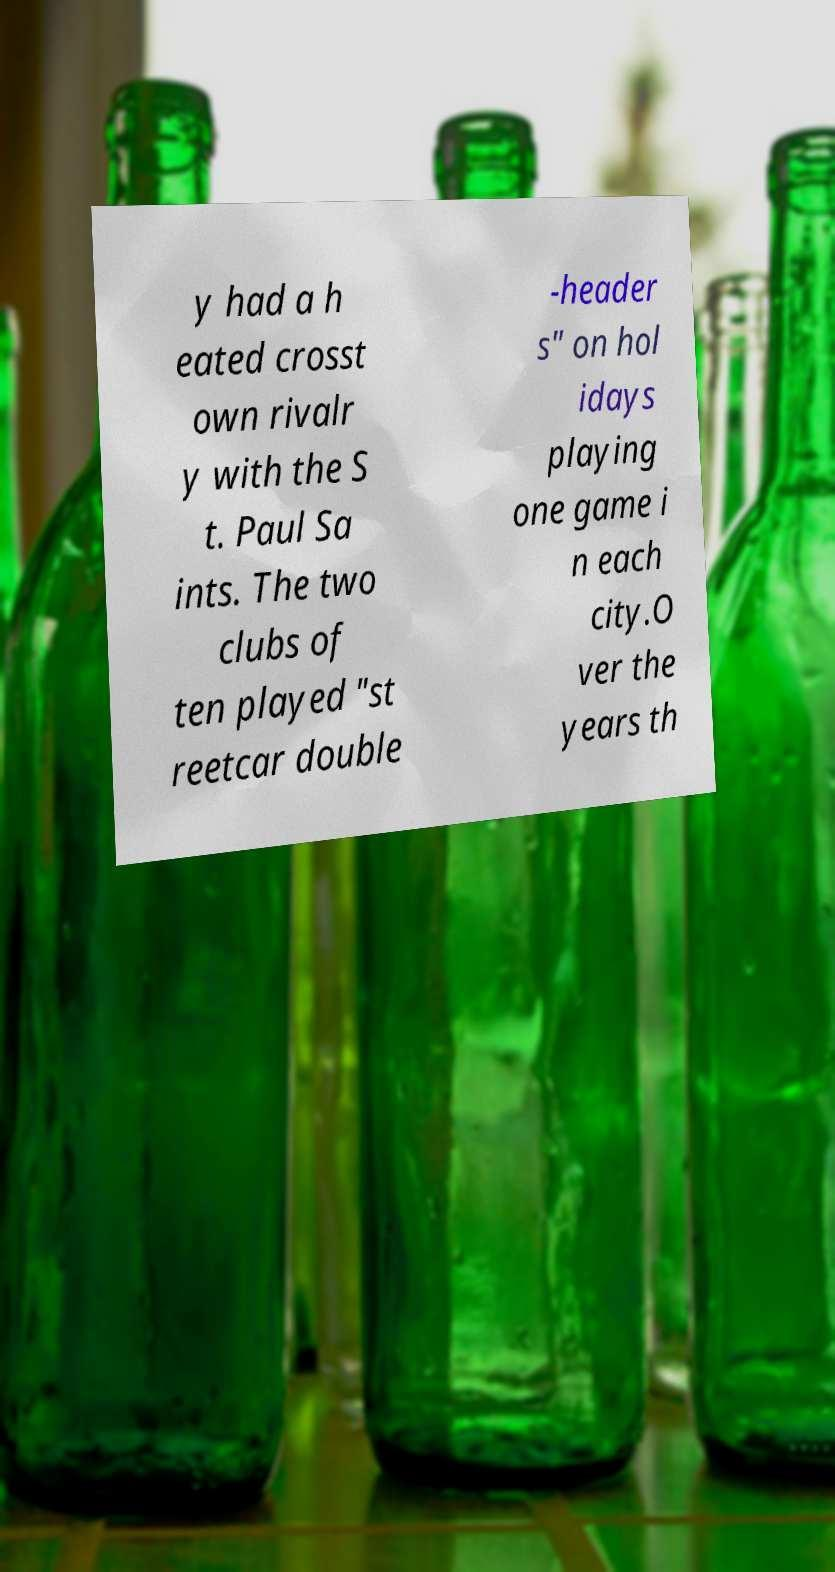Please read and relay the text visible in this image. What does it say? y had a h eated crosst own rivalr y with the S t. Paul Sa ints. The two clubs of ten played "st reetcar double -header s" on hol idays playing one game i n each city.O ver the years th 